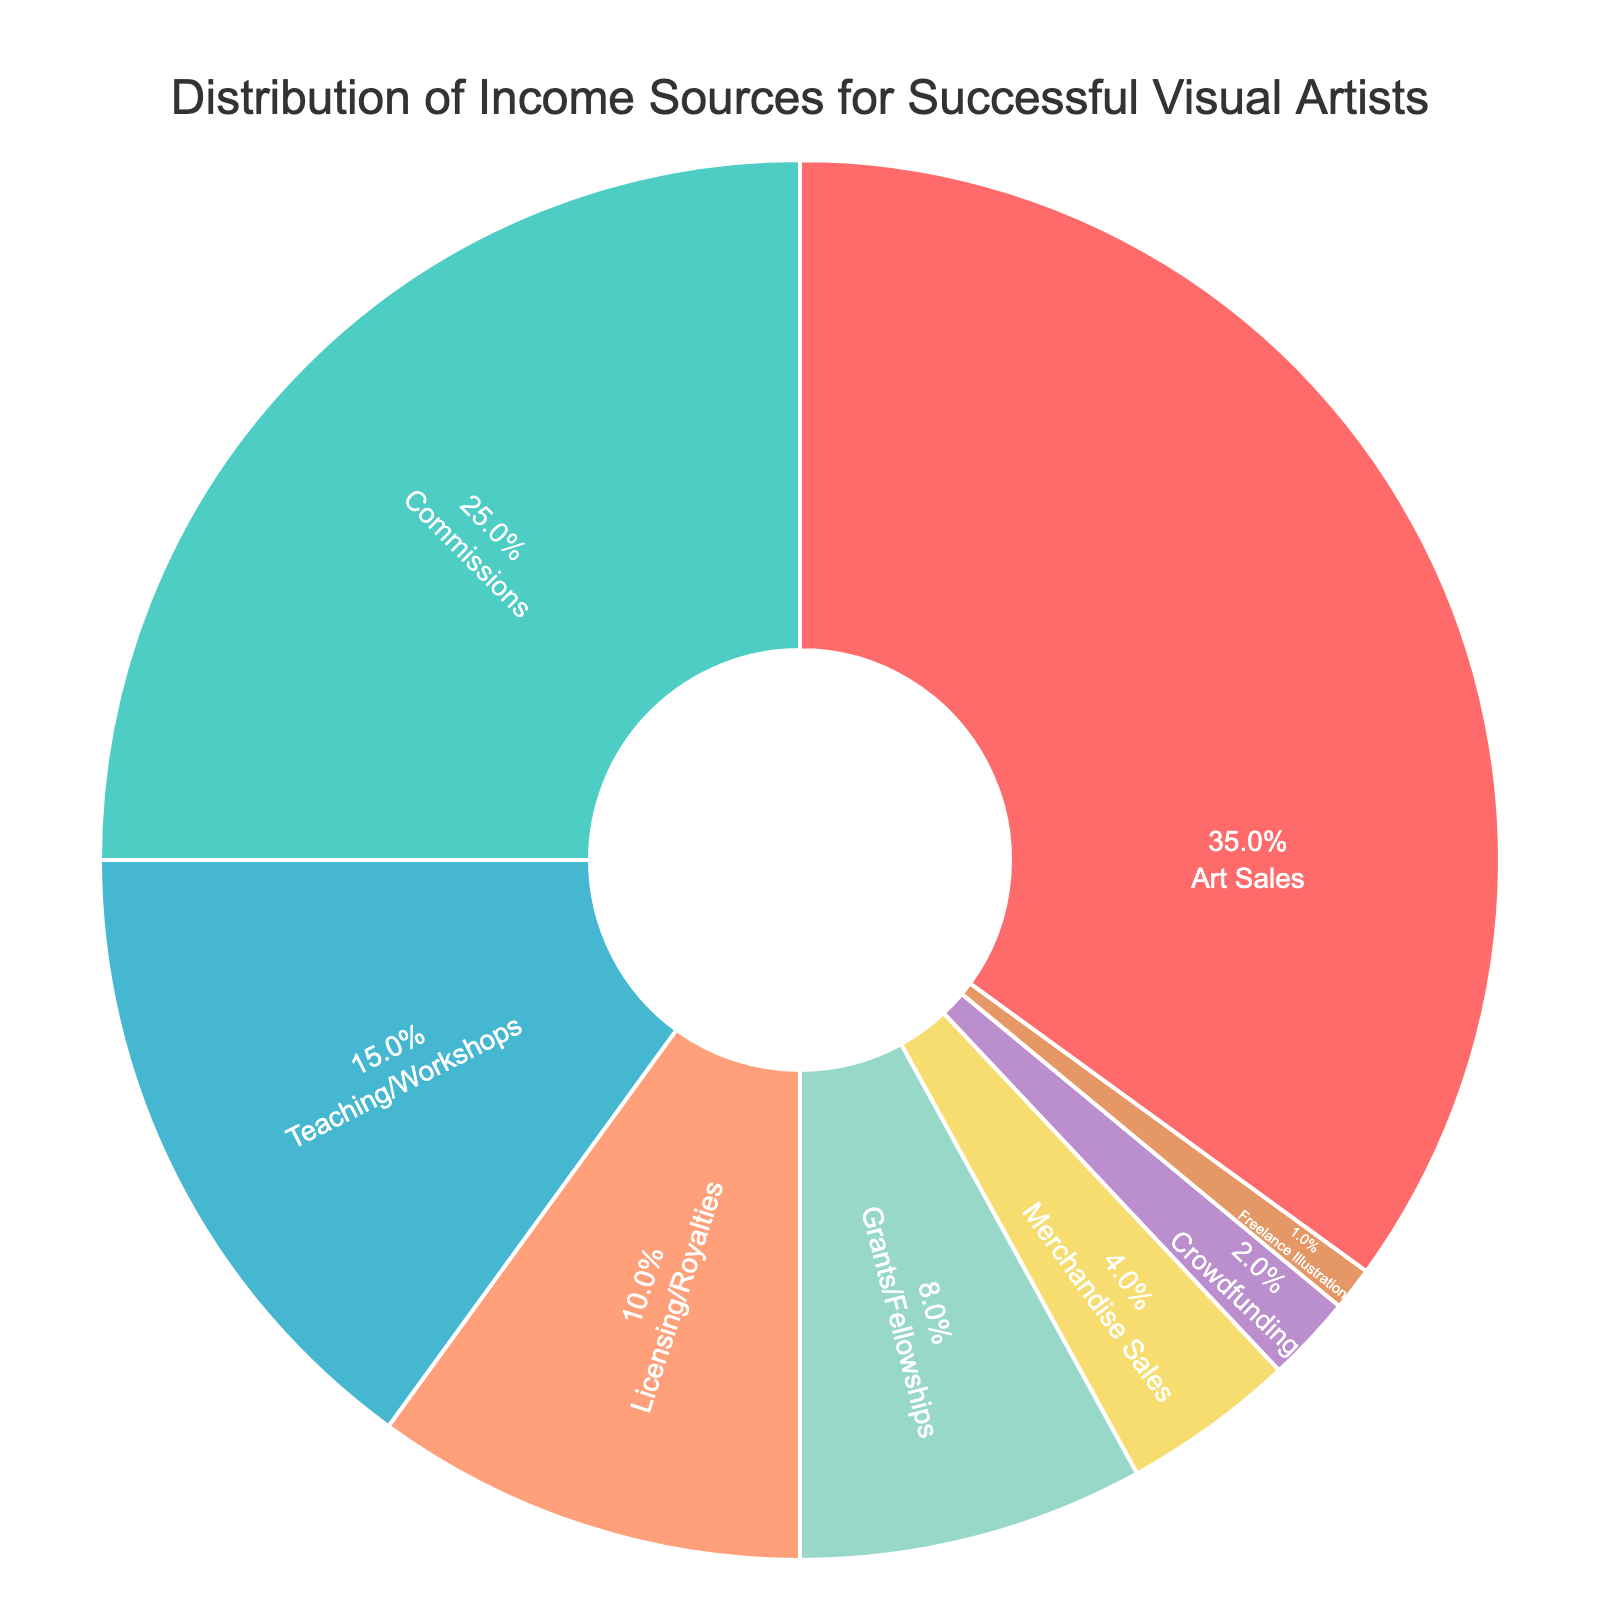Which income source has the highest percentage? By examining the pie chart, the section with the largest area represents the highest percentage. The "Art Sales" section is the largest.
Answer: Art Sales What are the combined percentages of Commissions and Teaching/Workshops? To find the combined percentage, add the values for Commissions (25%) and Teaching/Workshops (15%). The sum is 25% + 15% = 40%.
Answer: 40% Is the percentage for Licensing/Royalties greater than that for Grants/Fellowships? By comparing the two segments, Licensing/Royalties is 10%, and Grants/Fellowships is 8%. Since 10% > 8%, the answer is yes.
Answer: Yes Which income sources account for less than 5% of the total income? The sections representing Merchandise Sales (4%), Crowdfunding (2%), and Freelance Illustration (1%) are all less than 5%.
Answer: Merchandise Sales, Crowdfunding, Freelance Illustration Compare the percentage of income from Art Sales to that of Grants/Fellowships. Which is greater and by how much? Art Sales is 35% and Grants/Fellowships is 8%. Subtract the smaller percentage from the larger one: 35% - 8% = 27%. Art Sales is greater by 27%.
Answer: Art Sales by 27% What is the median percentage among all income sources listed? To find the median, list the percentages in ascending order: 1%, 2%, 4%, 8%, 10%, 15%, 25%, 35%. The middle values are 8% and 10%. The median is the average of these two: (8% + 10%) / 2 = 9%.
Answer: 9% Which two income sources, when combined, equal 50%? Summing the percentages of different pairs until reaching 50%, we find that Art Sales (35%) + Commissions (25%) = 60%, which is too high. Next pair: Art Sales (35%) + Teaching/Workshops (15%) = 50%.
Answer: Art Sales and Teaching/Workshops If you exclude Art Sales, what percentage of the total income contribution does the next largest source provide? After excluding Art Sales, the next largest segment is Commissions at 25%.
Answer: 25% What message is included in the chart annotation? The pie chart includes a message below it that says, "Embrace diverse income streams to thrive in the art world!"
Answer: Embrace diverse income streams to thrive in the art world! How much larger is the percentage for Art Sales compared to that for Crowdfunding? The percentage for Art Sales is 35%, and for Crowdfunding, it is 2%. Subtracting the smaller from the larger gives: 35% - 2% = 33%.
Answer: 33% 